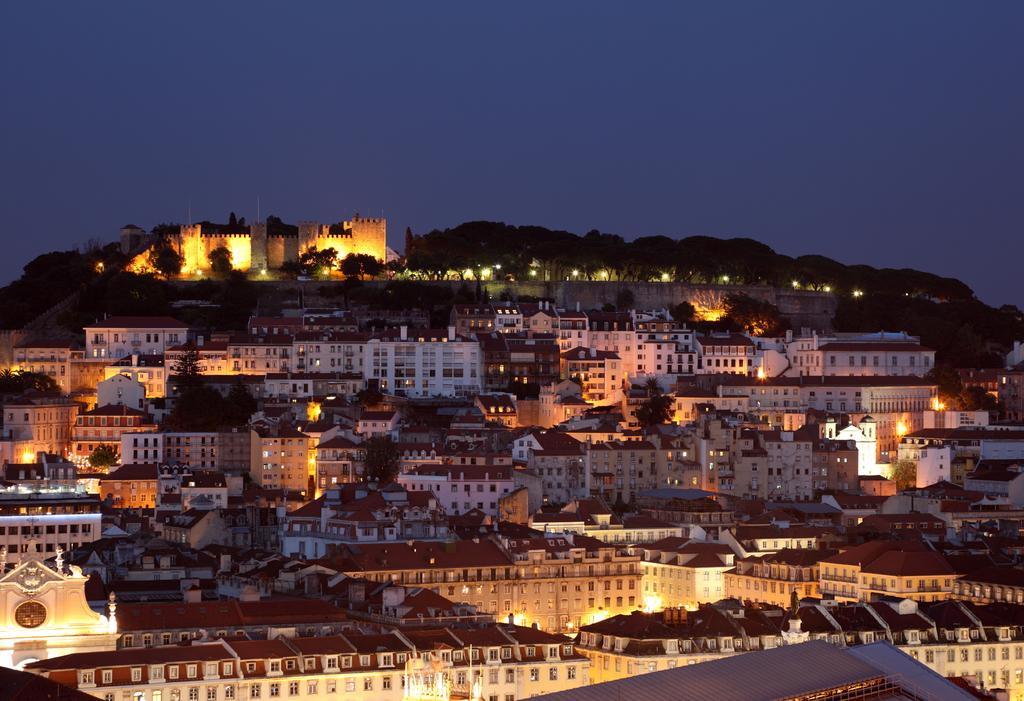What is the primary subject of the image? The primary subject of the image is many buildings. Can you describe the background of the image? The background of the image includes trees. How many toes are visible on the buildings in the image? There are no toes visible in the image, as it features buildings and trees. 